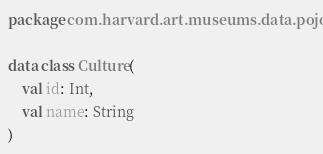Convert code to text. <code><loc_0><loc_0><loc_500><loc_500><_Kotlin_>package com.harvard.art.museums.data.pojo

data class Culture(
    val id: Int,
    val name: String
)</code> 